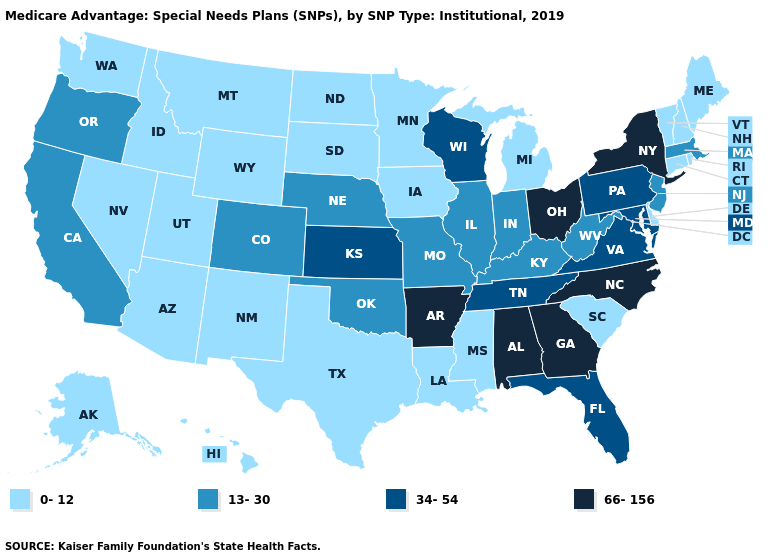Name the states that have a value in the range 13-30?
Short answer required. California, Colorado, Illinois, Indiana, Kentucky, Massachusetts, Missouri, Nebraska, New Jersey, Oklahoma, Oregon, West Virginia. What is the highest value in the MidWest ?
Give a very brief answer. 66-156. Name the states that have a value in the range 0-12?
Be succinct. Alaska, Arizona, Connecticut, Delaware, Hawaii, Idaho, Iowa, Louisiana, Maine, Michigan, Minnesota, Mississippi, Montana, Nevada, New Hampshire, New Mexico, North Dakota, Rhode Island, South Carolina, South Dakota, Texas, Utah, Vermont, Washington, Wyoming. Among the states that border Nebraska , which have the lowest value?
Quick response, please. Iowa, South Dakota, Wyoming. Does Nevada have the lowest value in the USA?
Answer briefly. Yes. What is the lowest value in the USA?
Keep it brief. 0-12. Name the states that have a value in the range 13-30?
Short answer required. California, Colorado, Illinois, Indiana, Kentucky, Massachusetts, Missouri, Nebraska, New Jersey, Oklahoma, Oregon, West Virginia. Among the states that border Vermont , does Massachusetts have the lowest value?
Write a very short answer. No. Name the states that have a value in the range 66-156?
Answer briefly. Alabama, Arkansas, Georgia, New York, North Carolina, Ohio. What is the lowest value in the South?
Give a very brief answer. 0-12. What is the highest value in the South ?
Keep it brief. 66-156. Does Maine have the same value as Rhode Island?
Concise answer only. Yes. Does Tennessee have the lowest value in the USA?
Keep it brief. No. How many symbols are there in the legend?
Keep it brief. 4. Does Texas have the lowest value in the USA?
Concise answer only. Yes. 